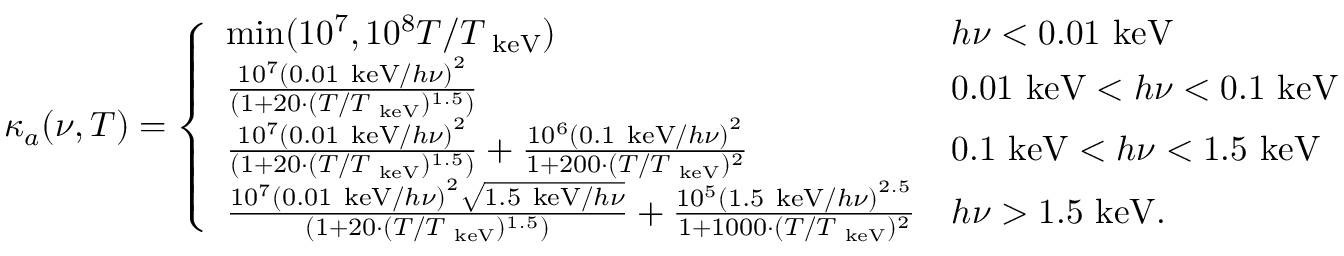Convert formula to latex. <formula><loc_0><loc_0><loc_500><loc_500>\kappa _ { a } ( \nu , T ) = \left \{ \begin{array} { l l } { \min ( 1 0 ^ { 7 } , 1 0 ^ { 8 } T / T _ { k e V } ) } & { h \nu < 0 . 0 1 k e V } \\ { \frac { 1 0 ^ { 7 } \left ( 0 . 0 1 k e V / h \nu \right ) ^ { 2 } } { ( 1 + 2 0 \cdot ( T / T _ { k e V } ) ^ { 1 . 5 } ) } } & { 0 . 0 1 k e V < h \nu < 0 . 1 k e V } \\ { \frac { 1 0 ^ { 7 } \left ( 0 . 0 1 k e V / h \nu \right ) ^ { 2 } } { ( 1 + 2 0 \cdot ( T / T _ { k e V } ) ^ { 1 . 5 } ) } + \frac { 1 0 ^ { 6 } \left ( 0 . 1 k e V / h \nu \right ) ^ { 2 } } { 1 + 2 0 0 \cdot ( T / T _ { k e V } ) ^ { 2 } } } & { 0 . 1 k e V < h \nu < 1 . 5 k e V } \\ { \frac { 1 0 ^ { 7 } \left ( 0 . 0 1 k e V / h \nu \right ) ^ { 2 } \sqrt { 1 . 5 k e V / h \nu } } { ( 1 + 2 0 \cdot ( T / T _ { k e V } ) ^ { 1 . 5 } ) } + \frac { 1 0 ^ { 5 } \left ( 1 . 5 k e V / h \nu \right ) ^ { 2 . 5 } } { 1 + 1 0 0 0 \cdot ( T / T _ { k e V } ) ^ { 2 } } } & { h \nu > 1 . 5 k e V . } \end{array}</formula> 